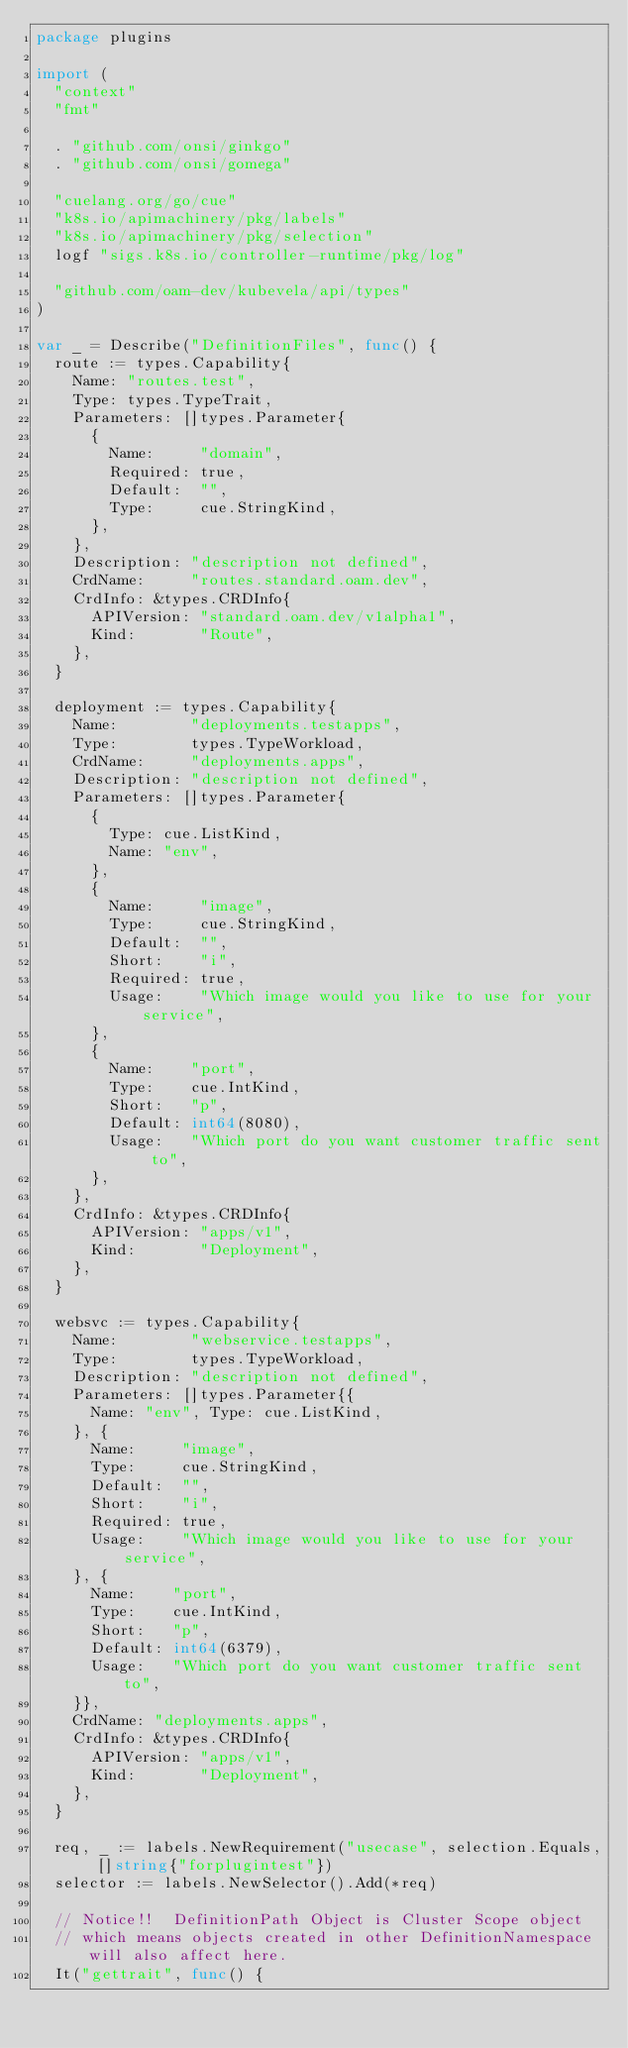Convert code to text. <code><loc_0><loc_0><loc_500><loc_500><_Go_>package plugins

import (
	"context"
	"fmt"

	. "github.com/onsi/ginkgo"
	. "github.com/onsi/gomega"

	"cuelang.org/go/cue"
	"k8s.io/apimachinery/pkg/labels"
	"k8s.io/apimachinery/pkg/selection"
	logf "sigs.k8s.io/controller-runtime/pkg/log"

	"github.com/oam-dev/kubevela/api/types"
)

var _ = Describe("DefinitionFiles", func() {
	route := types.Capability{
		Name: "routes.test",
		Type: types.TypeTrait,
		Parameters: []types.Parameter{
			{
				Name:     "domain",
				Required: true,
				Default:  "",
				Type:     cue.StringKind,
			},
		},
		Description: "description not defined",
		CrdName:     "routes.standard.oam.dev",
		CrdInfo: &types.CRDInfo{
			APIVersion: "standard.oam.dev/v1alpha1",
			Kind:       "Route",
		},
	}

	deployment := types.Capability{
		Name:        "deployments.testapps",
		Type:        types.TypeWorkload,
		CrdName:     "deployments.apps",
		Description: "description not defined",
		Parameters: []types.Parameter{
			{
				Type: cue.ListKind,
				Name: "env",
			},
			{
				Name:     "image",
				Type:     cue.StringKind,
				Default:  "",
				Short:    "i",
				Required: true,
				Usage:    "Which image would you like to use for your service",
			},
			{
				Name:    "port",
				Type:    cue.IntKind,
				Short:   "p",
				Default: int64(8080),
				Usage:   "Which port do you want customer traffic sent to",
			},
		},
		CrdInfo: &types.CRDInfo{
			APIVersion: "apps/v1",
			Kind:       "Deployment",
		},
	}

	websvc := types.Capability{
		Name:        "webservice.testapps",
		Type:        types.TypeWorkload,
		Description: "description not defined",
		Parameters: []types.Parameter{{
			Name: "env", Type: cue.ListKind,
		}, {
			Name:     "image",
			Type:     cue.StringKind,
			Default:  "",
			Short:    "i",
			Required: true,
			Usage:    "Which image would you like to use for your service",
		}, {
			Name:    "port",
			Type:    cue.IntKind,
			Short:   "p",
			Default: int64(6379),
			Usage:   "Which port do you want customer traffic sent to",
		}},
		CrdName: "deployments.apps",
		CrdInfo: &types.CRDInfo{
			APIVersion: "apps/v1",
			Kind:       "Deployment",
		},
	}

	req, _ := labels.NewRequirement("usecase", selection.Equals, []string{"forplugintest"})
	selector := labels.NewSelector().Add(*req)

	// Notice!!  DefinitionPath Object is Cluster Scope object
	// which means objects created in other DefinitionNamespace will also affect here.
	It("gettrait", func() {</code> 